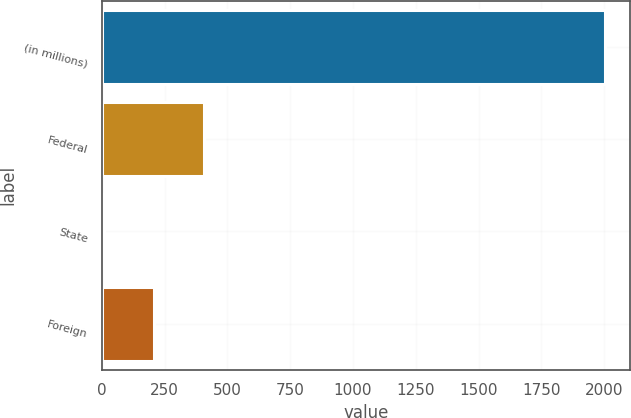Convert chart to OTSL. <chart><loc_0><loc_0><loc_500><loc_500><bar_chart><fcel>(in millions)<fcel>Federal<fcel>State<fcel>Foreign<nl><fcel>2002<fcel>408.4<fcel>10<fcel>209.2<nl></chart> 